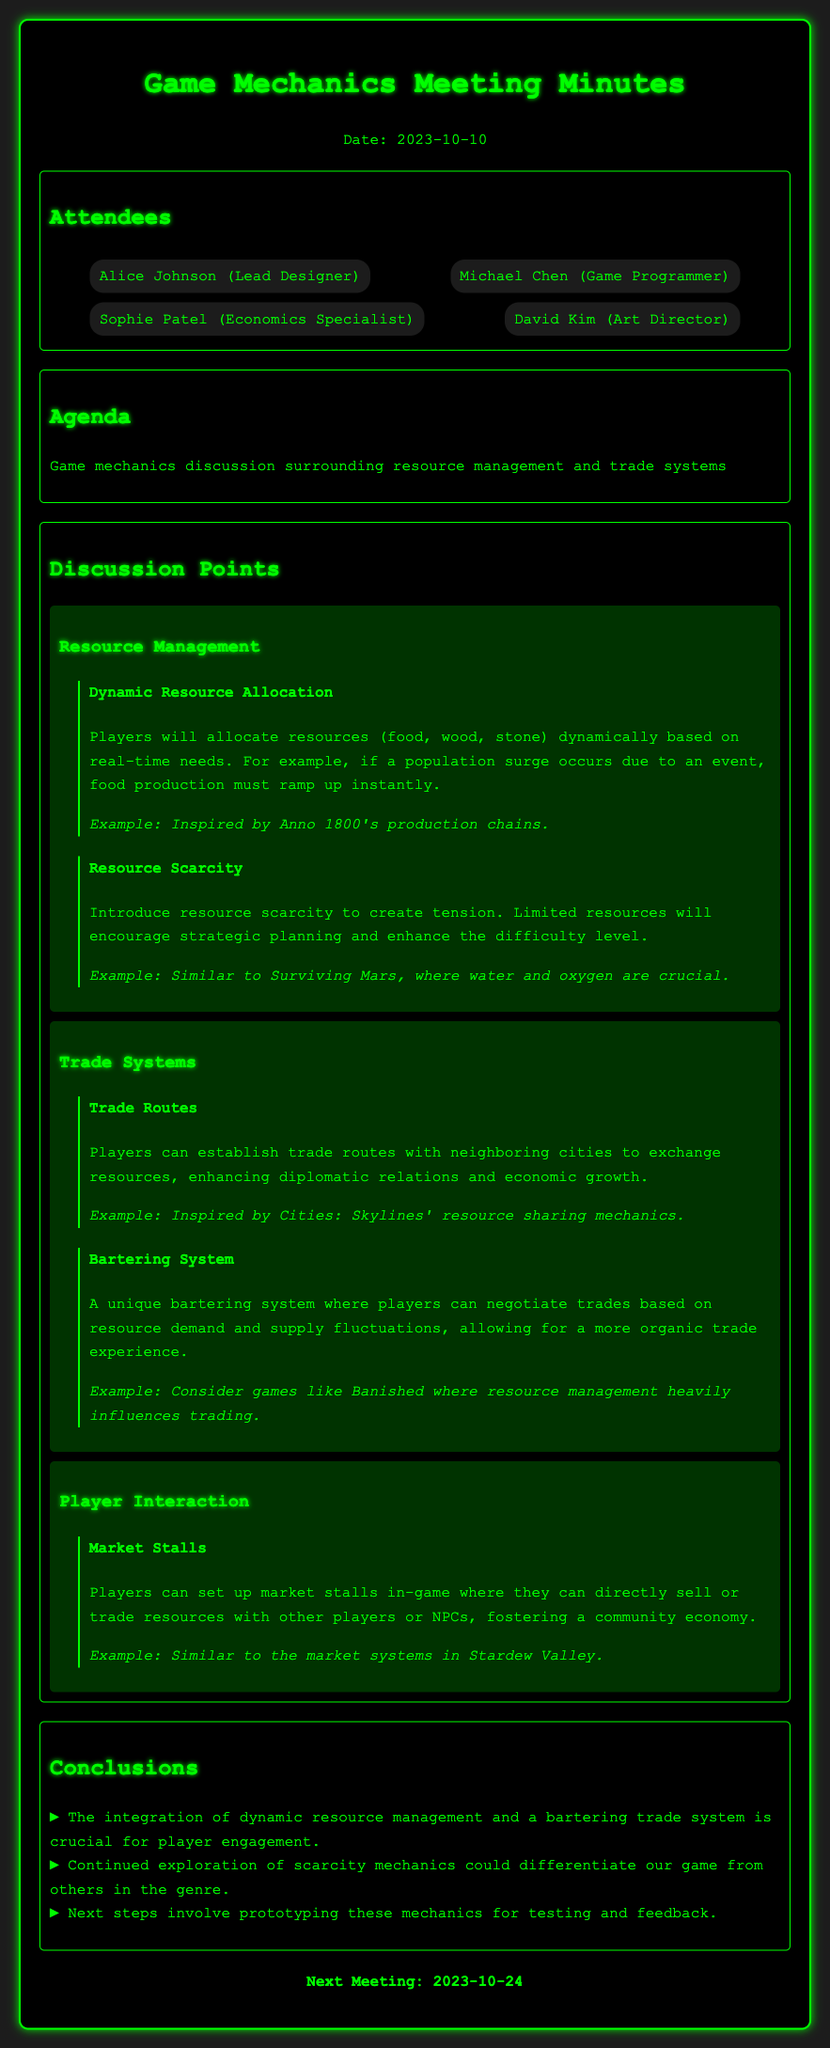what is the date of the meeting? The date of the meeting is specified in the header section of the document.
Answer: 2023-10-10 who is the Lead Designer? The Lead Designer's name is mentioned in the attendees section of the document.
Answer: Alice Johnson what is one example of dynamic resource allocation? An example is provided in the discussion on resource management, specifically mentioning a game.
Answer: Anno 1800 what are players establishing with neighboring cities? The players can establish a specific interaction mentioned in the trade systems section.
Answer: Trade routes which game inspired the resource scarcity discussion? The document provides a reference to a game that illustrates resource scarcity in the mechanics discussion.
Answer: Surviving Mars what is a unique feature of the bartering system? The discussion on trade systems points out the nature of this system regarding trading.
Answer: Negotiating trades how many attendees are listed? The number of attendees is counted in the attendees section of the document.
Answer: Four what is one next step mentioned in the conclusions? The conclusions outline future actions to be taken following the meeting discussions.
Answer: Prototyping these mechanics 